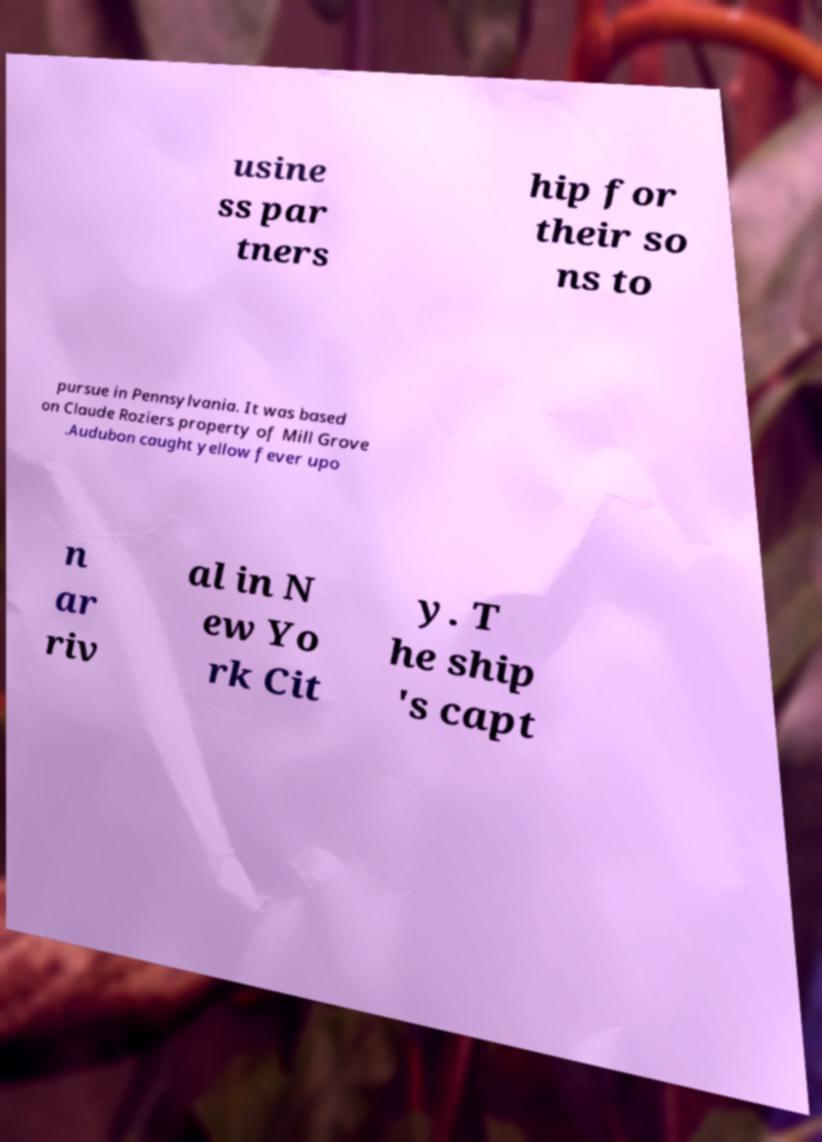Could you extract and type out the text from this image? usine ss par tners hip for their so ns to pursue in Pennsylvania. It was based on Claude Roziers property of Mill Grove .Audubon caught yellow fever upo n ar riv al in N ew Yo rk Cit y. T he ship 's capt 